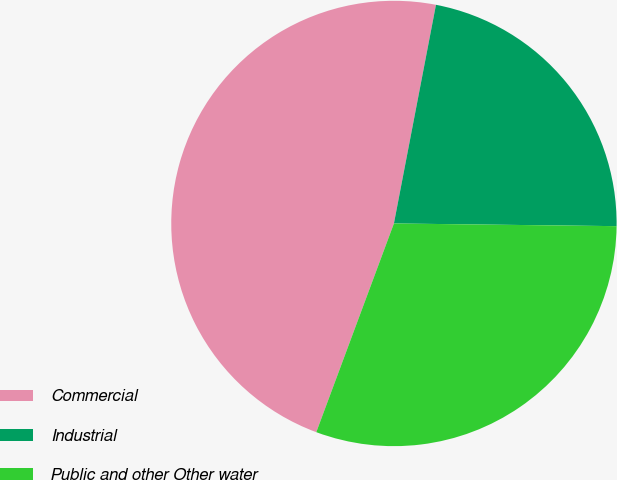Convert chart. <chart><loc_0><loc_0><loc_500><loc_500><pie_chart><fcel>Commercial<fcel>Industrial<fcel>Public and other Other water<nl><fcel>47.36%<fcel>22.17%<fcel>30.48%<nl></chart> 